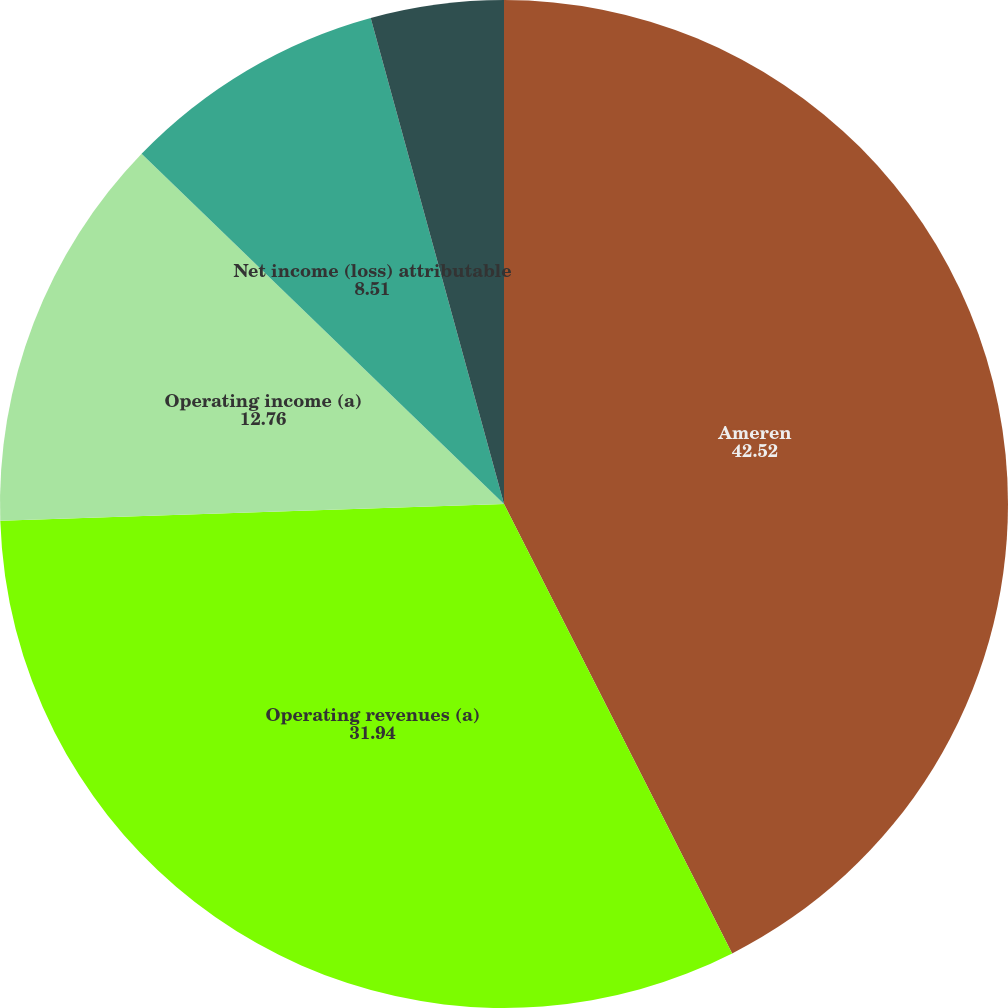<chart> <loc_0><loc_0><loc_500><loc_500><pie_chart><fcel>Ameren<fcel>Operating revenues (a)<fcel>Operating income (a)<fcel>Net income (loss) attributable<fcel>Earnings (loss) per common<nl><fcel>42.52%<fcel>31.94%<fcel>12.76%<fcel>8.51%<fcel>4.26%<nl></chart> 